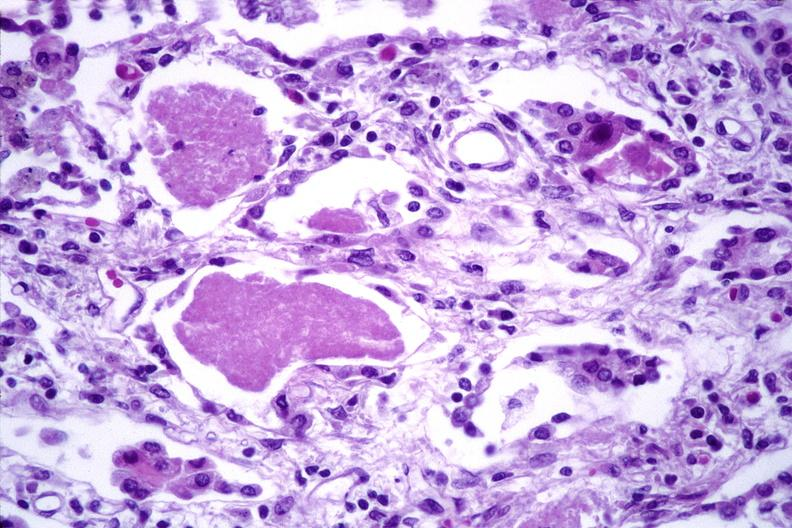does this image show lung, cyomegalovirus pneumonia and pneumocystis pneumonia?
Answer the question using a single word or phrase. Yes 